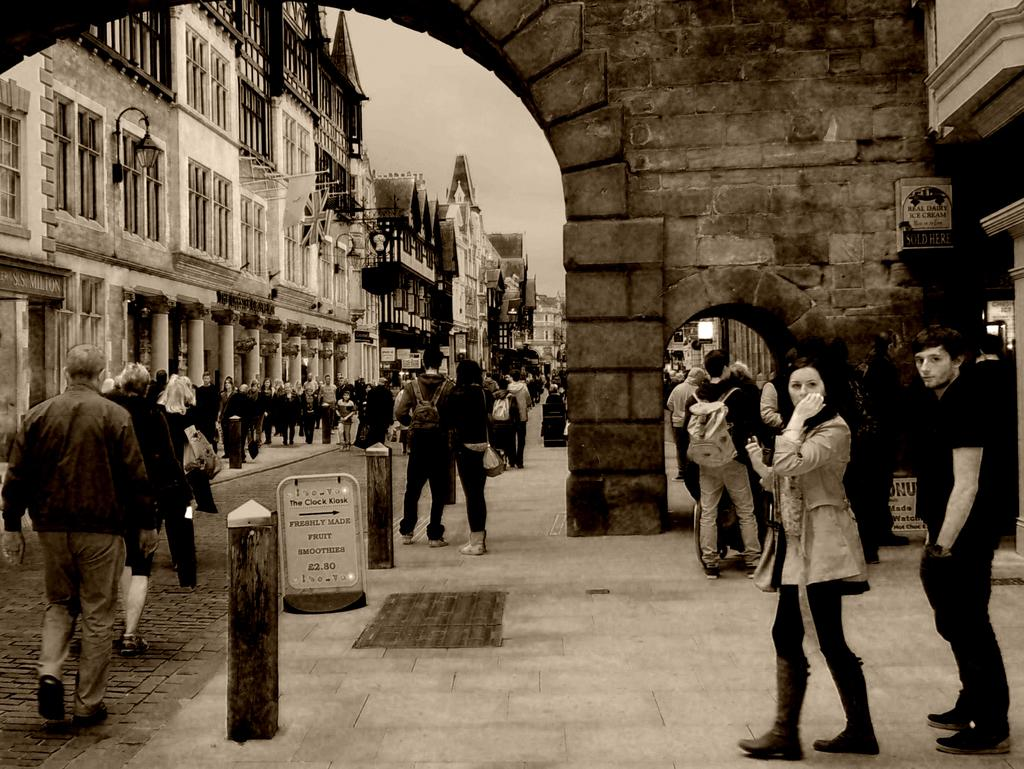What is the color scheme of the image? The image is black and white. What can be seen in the image besides the color scheme? There is a group of people standing in the image, along with buildings, boards, and lights. What is visible in the background of the image? The sky is visible in the background of the image. How many girls with long hair can be seen on the side of the image? There is no mention of girls or hair in the provided facts, so it cannot be determined from the image. 